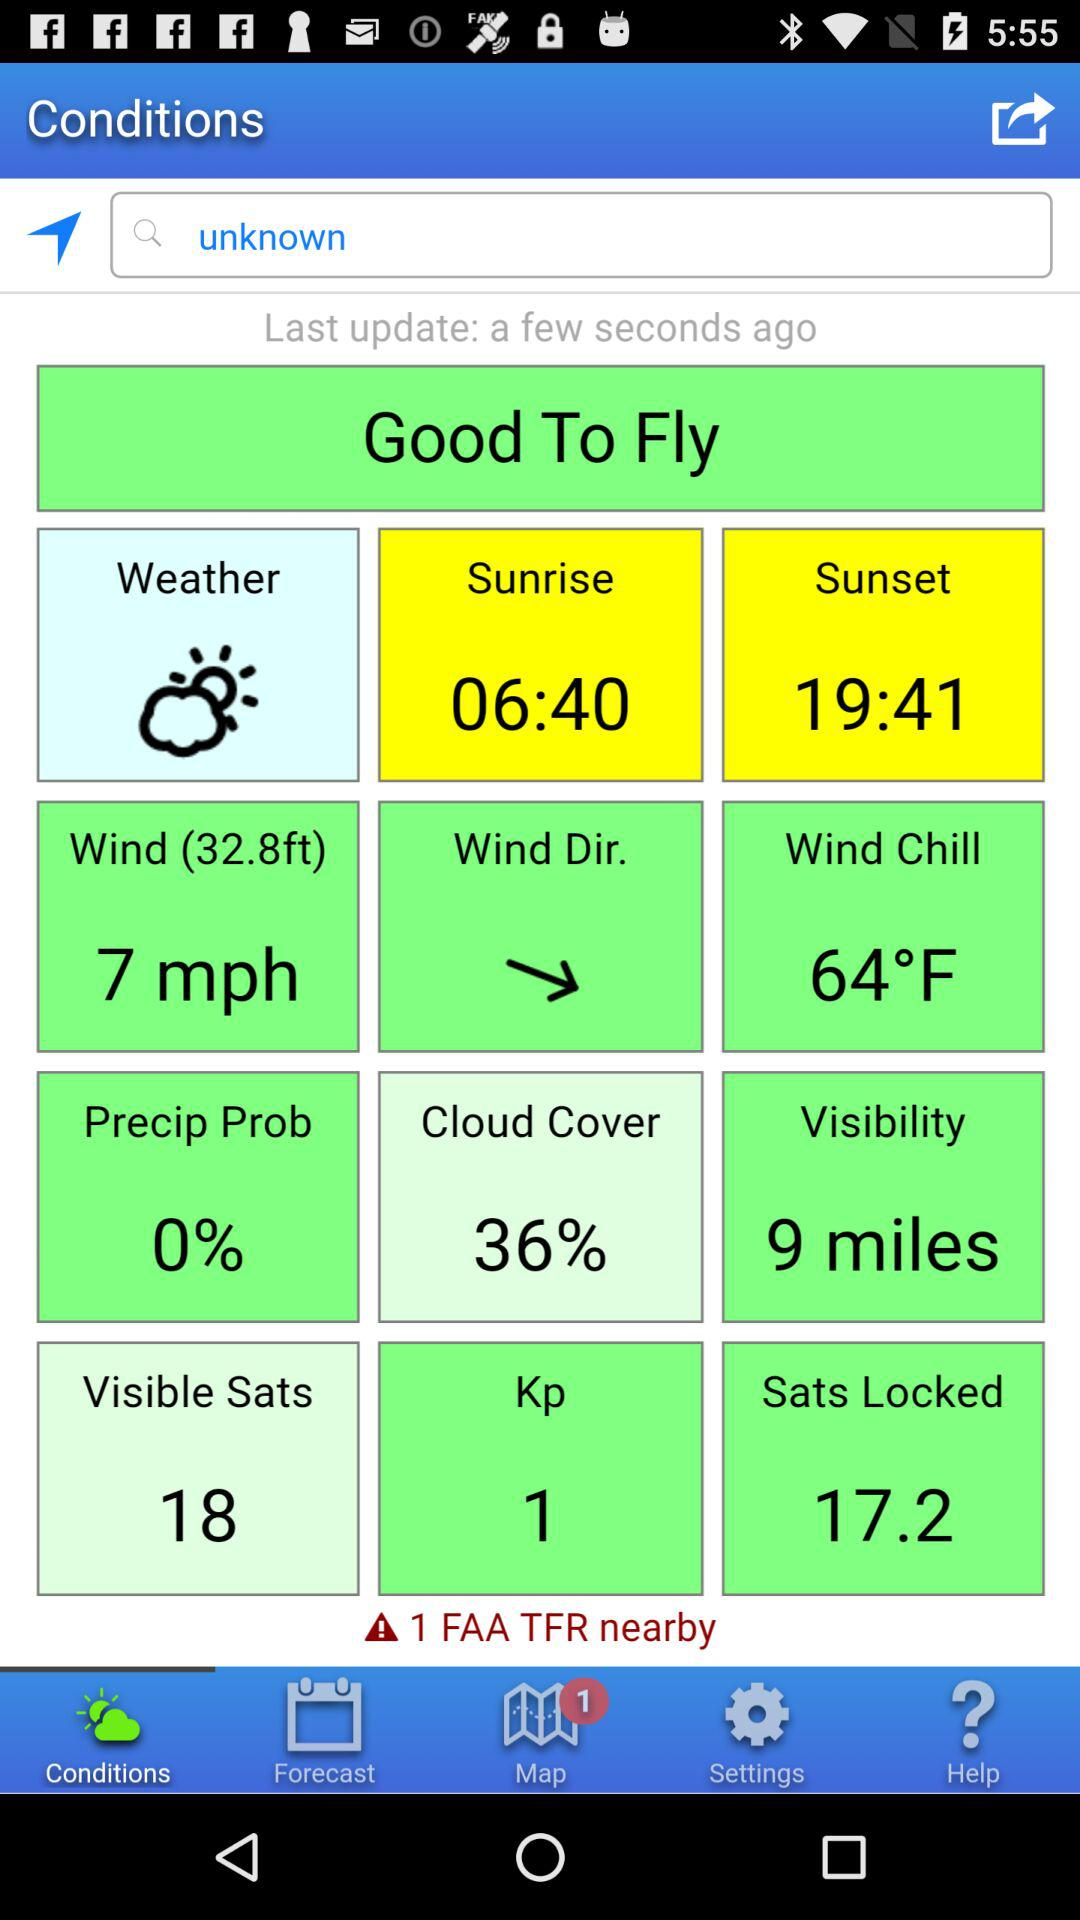How many TFRs are nearby?
Answer the question using a single word or phrase. 1 